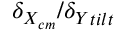<formula> <loc_0><loc_0><loc_500><loc_500>\delta _ { X _ { c m } } / { \delta _ { Y } } _ { t i l t }</formula> 